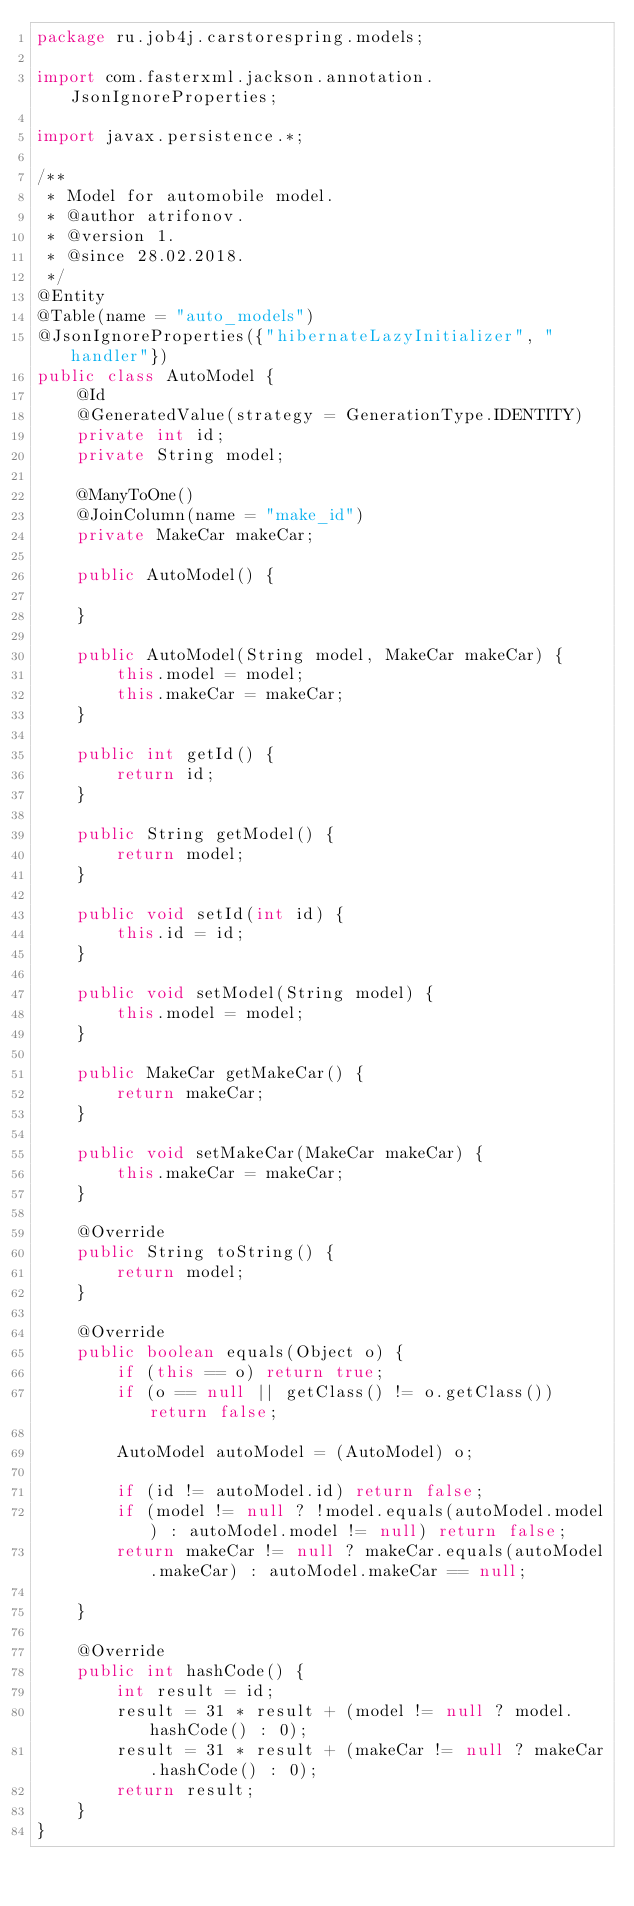<code> <loc_0><loc_0><loc_500><loc_500><_Java_>package ru.job4j.carstorespring.models;

import com.fasterxml.jackson.annotation.JsonIgnoreProperties;

import javax.persistence.*;

/**
 * Model for automobile model.
 * @author atrifonov.
 * @version 1.
 * @since 28.02.2018.
 */
@Entity
@Table(name = "auto_models")
@JsonIgnoreProperties({"hibernateLazyInitializer", "handler"})
public class AutoModel {
    @Id
    @GeneratedValue(strategy = GenerationType.IDENTITY)
    private int id;
    private String model;

    @ManyToOne()
    @JoinColumn(name = "make_id")
    private MakeCar makeCar;

    public AutoModel() {

    }

    public AutoModel(String model, MakeCar makeCar) {
        this.model = model;
        this.makeCar = makeCar;
    }

    public int getId() {
        return id;
    }

    public String getModel() {
        return model;
    }

    public void setId(int id) {
        this.id = id;
    }

    public void setModel(String model) {
        this.model = model;
    }

    public MakeCar getMakeCar() {
        return makeCar;
    }

    public void setMakeCar(MakeCar makeCar) {
        this.makeCar = makeCar;
    }

    @Override
    public String toString() {
        return model;
    }

    @Override
    public boolean equals(Object o) {
        if (this == o) return true;
        if (o == null || getClass() != o.getClass()) return false;

        AutoModel autoModel = (AutoModel) o;

        if (id != autoModel.id) return false;
        if (model != null ? !model.equals(autoModel.model) : autoModel.model != null) return false;
        return makeCar != null ? makeCar.equals(autoModel.makeCar) : autoModel.makeCar == null;

    }

    @Override
    public int hashCode() {
        int result = id;
        result = 31 * result + (model != null ? model.hashCode() : 0);
        result = 31 * result + (makeCar != null ? makeCar.hashCode() : 0);
        return result;
    }
}</code> 